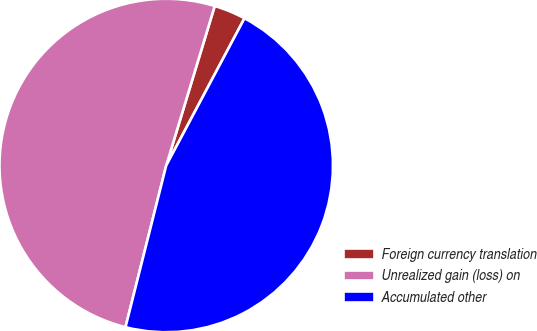Convert chart to OTSL. <chart><loc_0><loc_0><loc_500><loc_500><pie_chart><fcel>Foreign currency translation<fcel>Unrealized gain (loss) on<fcel>Accumulated other<nl><fcel>3.08%<fcel>50.77%<fcel>46.15%<nl></chart> 